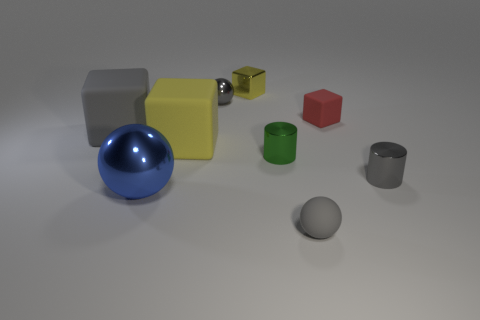Add 1 big brown metal blocks. How many objects exist? 10 Subtract all balls. How many objects are left? 6 Subtract all large yellow blocks. Subtract all tiny green cylinders. How many objects are left? 7 Add 3 cylinders. How many cylinders are left? 5 Add 1 blue spheres. How many blue spheres exist? 2 Subtract 0 cyan blocks. How many objects are left? 9 